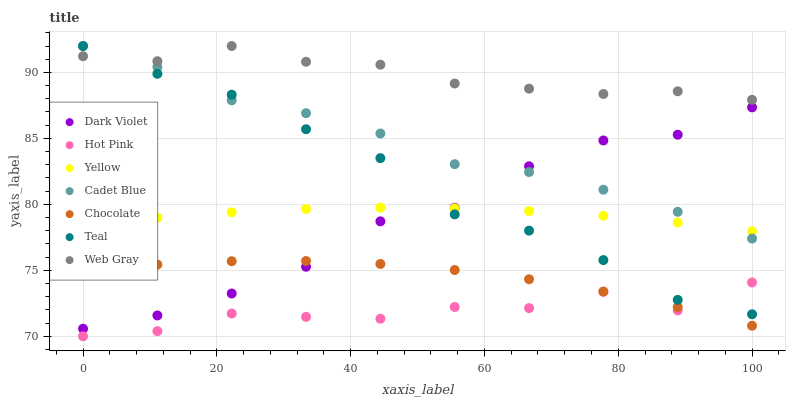Does Hot Pink have the minimum area under the curve?
Answer yes or no. Yes. Does Web Gray have the maximum area under the curve?
Answer yes or no. Yes. Does Yellow have the minimum area under the curve?
Answer yes or no. No. Does Yellow have the maximum area under the curve?
Answer yes or no. No. Is Yellow the smoothest?
Answer yes or no. Yes. Is Hot Pink the roughest?
Answer yes or no. Yes. Is Hot Pink the smoothest?
Answer yes or no. No. Is Yellow the roughest?
Answer yes or no. No. Does Hot Pink have the lowest value?
Answer yes or no. Yes. Does Yellow have the lowest value?
Answer yes or no. No. Does Teal have the highest value?
Answer yes or no. Yes. Does Yellow have the highest value?
Answer yes or no. No. Is Hot Pink less than Cadet Blue?
Answer yes or no. Yes. Is Teal greater than Chocolate?
Answer yes or no. Yes. Does Chocolate intersect Hot Pink?
Answer yes or no. Yes. Is Chocolate less than Hot Pink?
Answer yes or no. No. Is Chocolate greater than Hot Pink?
Answer yes or no. No. Does Hot Pink intersect Cadet Blue?
Answer yes or no. No. 